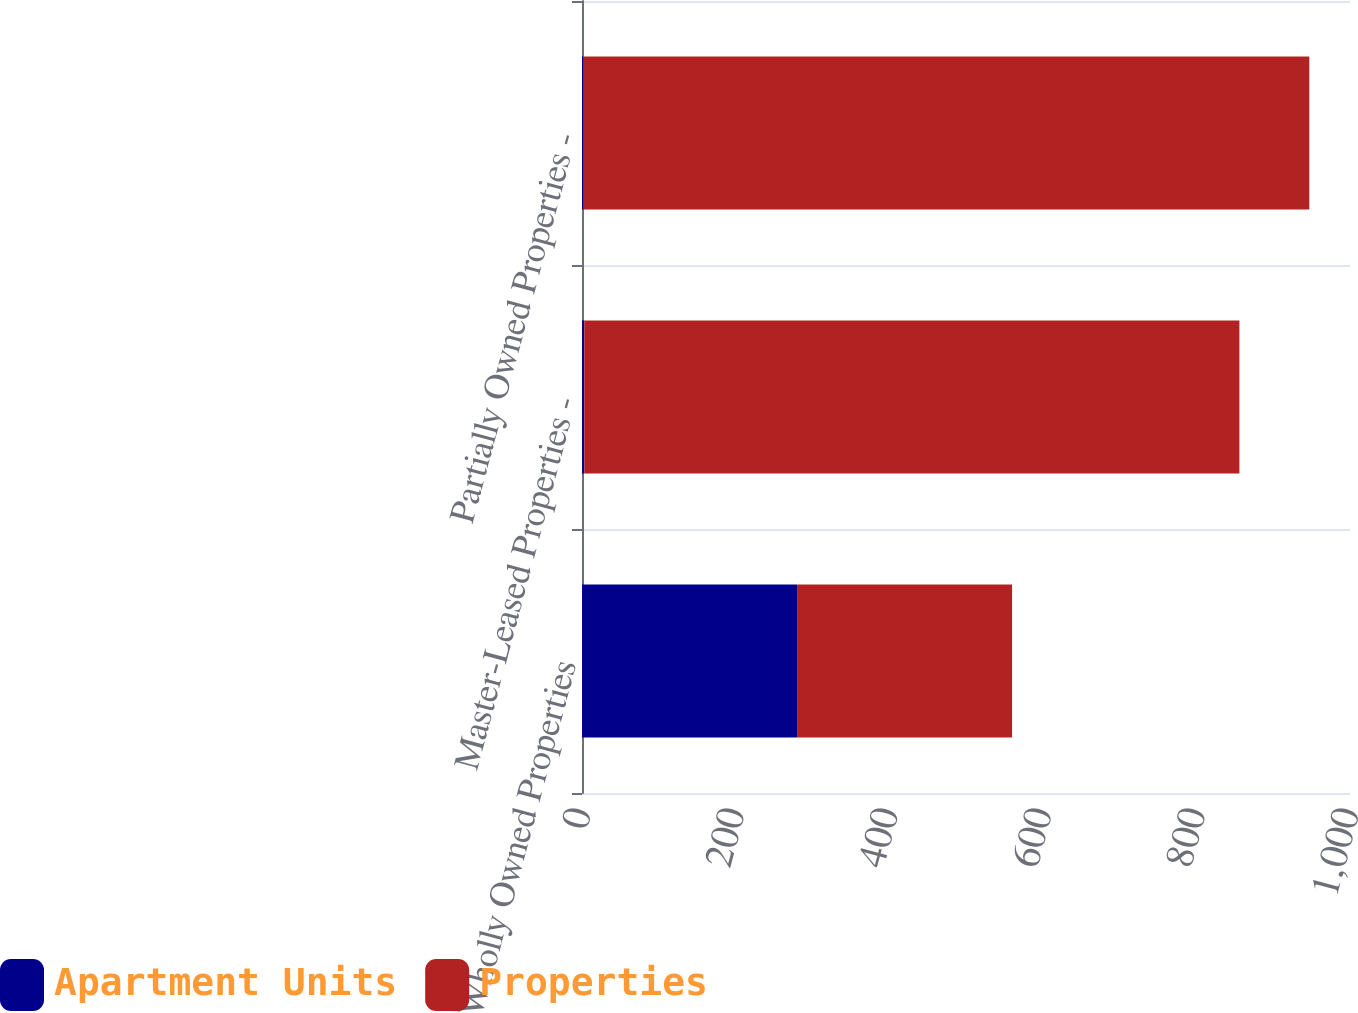<chart> <loc_0><loc_0><loc_500><loc_500><stacked_bar_chart><ecel><fcel>Wholly Owned Properties<fcel>Master-Leased Properties -<fcel>Partially Owned Properties -<nl><fcel>Apartment Units<fcel>280<fcel>3<fcel>2<nl><fcel>Properties<fcel>280<fcel>853<fcel>945<nl></chart> 